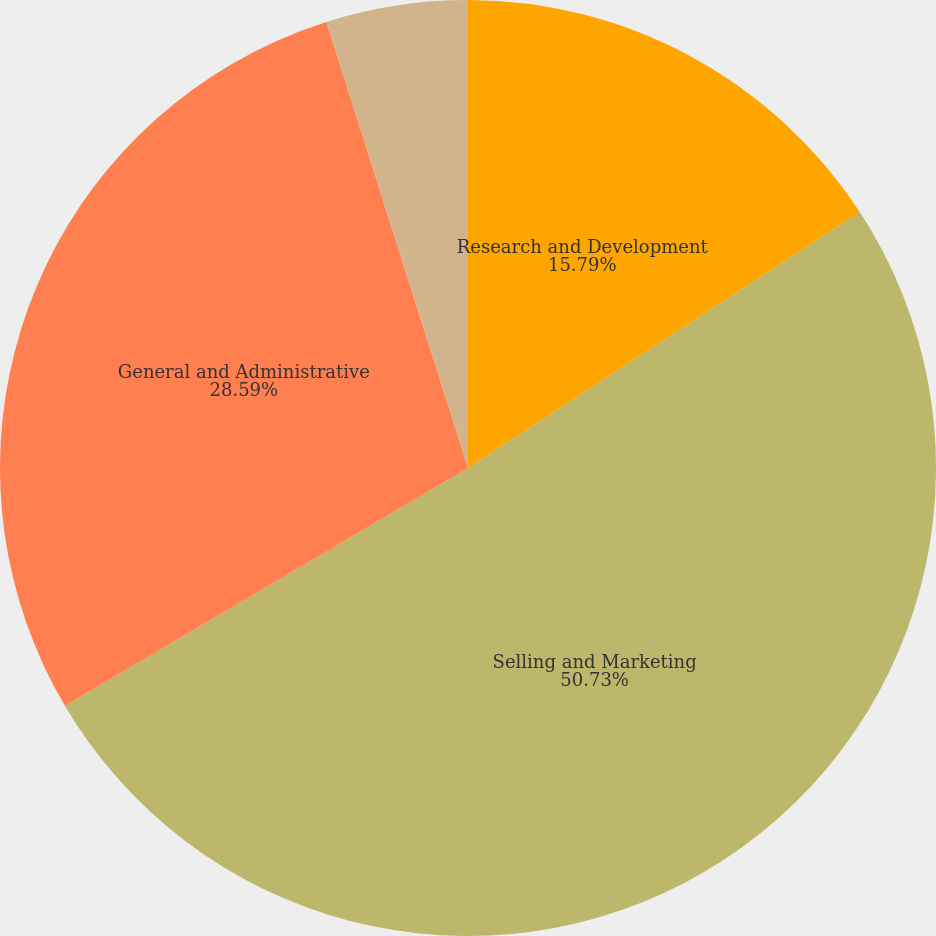Convert chart to OTSL. <chart><loc_0><loc_0><loc_500><loc_500><pie_chart><fcel>Research and Development<fcel>Selling and Marketing<fcel>General and Administrative<fcel>Amortization of Intangibles<nl><fcel>15.79%<fcel>50.72%<fcel>28.59%<fcel>4.89%<nl></chart> 